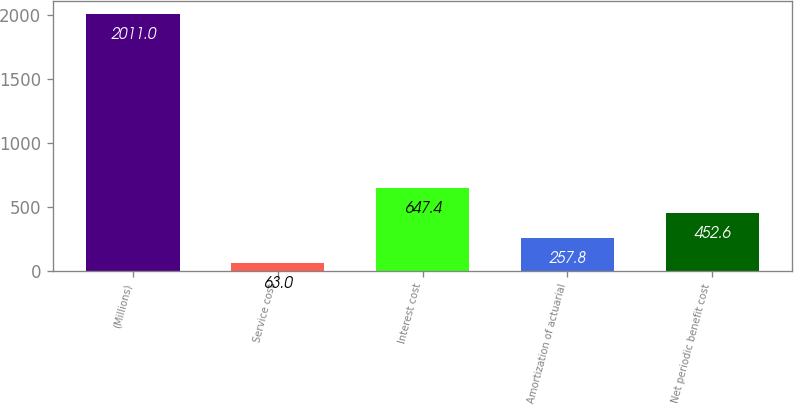Convert chart to OTSL. <chart><loc_0><loc_0><loc_500><loc_500><bar_chart><fcel>(Millions)<fcel>Service cost<fcel>Interest cost<fcel>Amortization of actuarial<fcel>Net periodic benefit cost<nl><fcel>2011<fcel>63<fcel>647.4<fcel>257.8<fcel>452.6<nl></chart> 